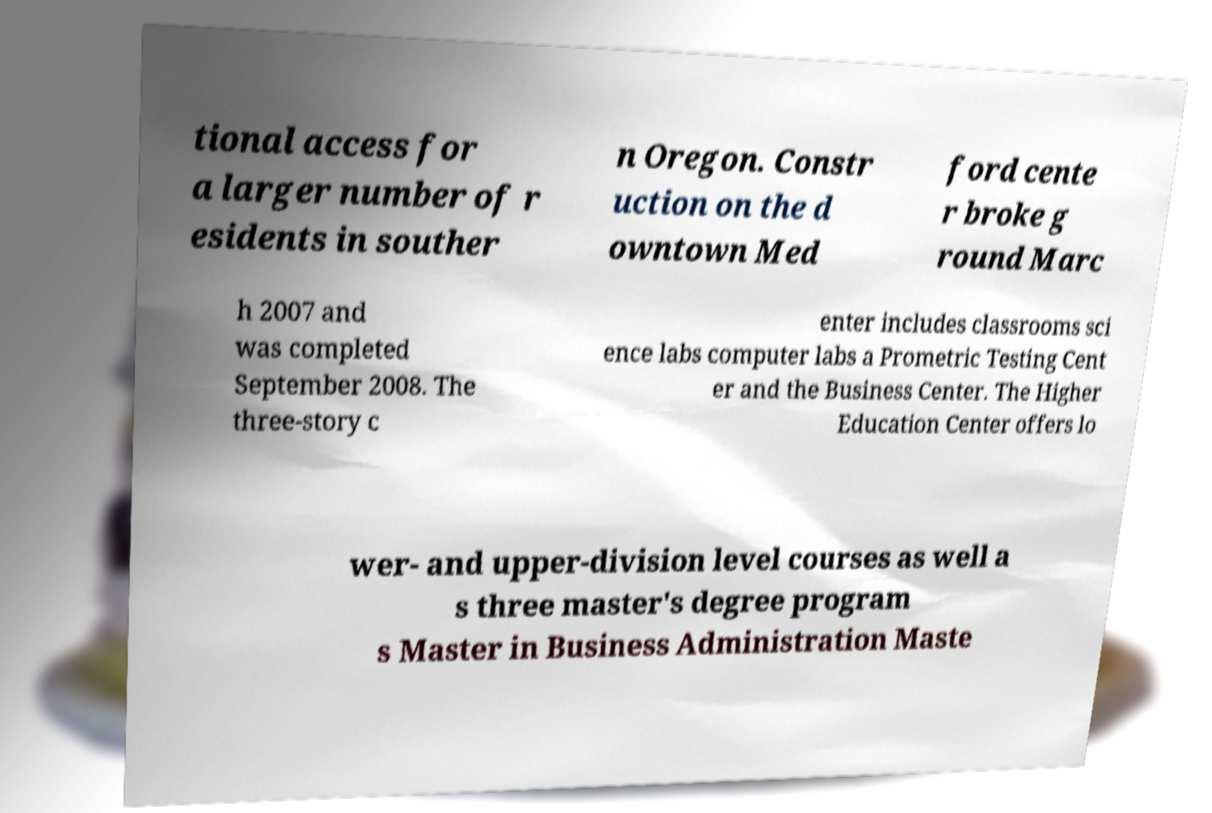What messages or text are displayed in this image? I need them in a readable, typed format. tional access for a larger number of r esidents in souther n Oregon. Constr uction on the d owntown Med ford cente r broke g round Marc h 2007 and was completed September 2008. The three-story c enter includes classrooms sci ence labs computer labs a Prometric Testing Cent er and the Business Center. The Higher Education Center offers lo wer- and upper-division level courses as well a s three master's degree program s Master in Business Administration Maste 